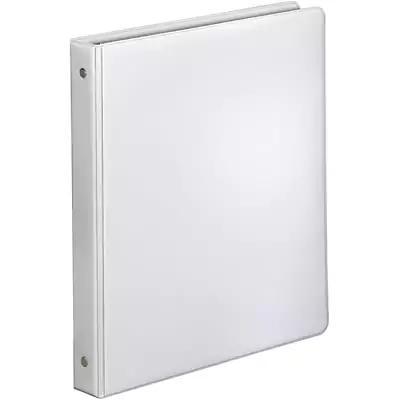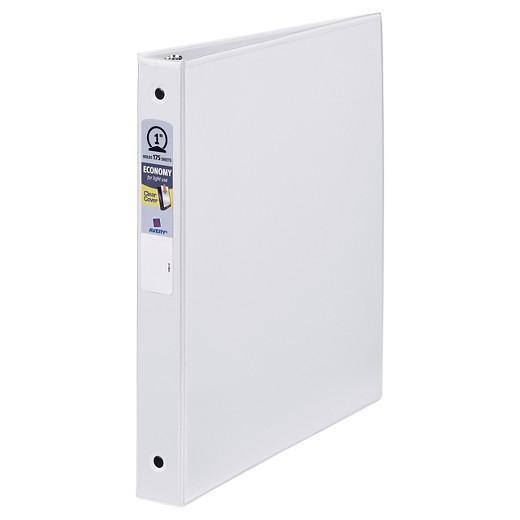The first image is the image on the left, the second image is the image on the right. Evaluate the accuracy of this statement regarding the images: "Both binders are purple.". Is it true? Answer yes or no. No. The first image is the image on the left, the second image is the image on the right. Given the left and right images, does the statement "Two solid purple binder notebooks are shown in a similar stance, on end with the opening to the back, and have no visible contents." hold true? Answer yes or no. No. 